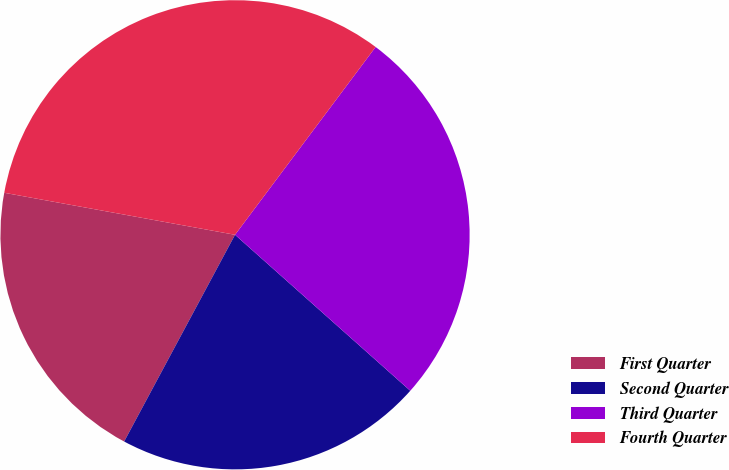Convert chart. <chart><loc_0><loc_0><loc_500><loc_500><pie_chart><fcel>First Quarter<fcel>Second Quarter<fcel>Third Quarter<fcel>Fourth Quarter<nl><fcel>20.03%<fcel>21.26%<fcel>26.35%<fcel>32.36%<nl></chart> 